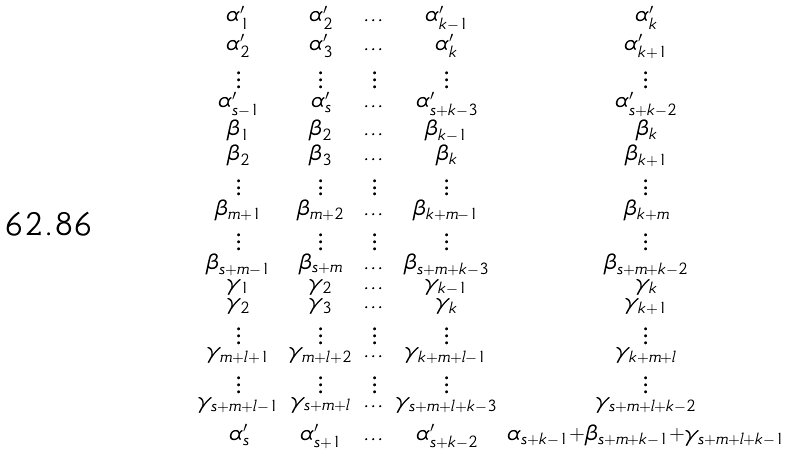Convert formula to latex. <formula><loc_0><loc_0><loc_500><loc_500>\begin{smallmatrix} \alpha _ { 1 } ^ { \prime } & \alpha _ { 2 } ^ { \prime } & \dots & \alpha _ { k - 1 } ^ { \prime } & \alpha _ { k } ^ { \prime } \\ \alpha _ { 2 } ^ { \prime } & \alpha _ { 3 } ^ { \prime } & \dots & \alpha _ { k } ^ { \prime } & \alpha _ { k + 1 } ^ { \prime } \\ \vdots & \vdots & \vdots & \vdots & \vdots \\ \alpha _ { s - 1 } ^ { \prime } & \alpha _ { s } ^ { \prime } & \dots & \alpha _ { s + k - 3 } ^ { \prime } & \alpha _ { s + k - 2 } ^ { \prime } \\ \beta _ { 1 } & \beta _ { 2 } & \dots & \beta _ { k - 1 } & \beta _ { k } \\ \beta _ { 2 } & \beta _ { 3 } & \dots & \beta _ { k } & \beta _ { k + 1 } \\ \vdots & \vdots & \vdots & \vdots & \vdots \\ \beta _ { m + 1 } & \beta _ { m + 2 } & \dots & \beta _ { k + m - 1 } & \beta _ { k + m } \\ \vdots & \vdots & \vdots & \vdots & \vdots \\ \beta _ { s + m - 1 } & \beta _ { s + m } & \dots & \beta _ { s + m + k - 3 } & \beta _ { s + m + k - 2 } \\ \gamma _ { 1 } & \gamma _ { 2 } & \dots & \gamma _ { k - 1 } & \gamma _ { k } \\ \gamma _ { 2 } & \gamma _ { 3 } & \dots & \gamma _ { k } & \gamma _ { k + 1 } \\ \vdots & \vdots & \vdots & \vdots & \vdots \\ \gamma _ { m + l + 1 } & \gamma _ { m + l + 2 } & \dots & \gamma _ { k + m + l - 1 } & \gamma _ { k + m + l } \\ \vdots & \vdots & \vdots & \vdots & \vdots \\ \gamma _ { s + m + l - 1 } & \gamma _ { s + m + l } & \dots & \gamma _ { s + m + l + k - 3 } & \gamma _ { s + m + l + k - 2 } \\ \\ \alpha _ { s } ^ { \prime } & \alpha _ { s + 1 } ^ { \prime } & \dots & \alpha _ { s + k - 2 } ^ { \prime } & \alpha _ { s + k - 1 } + \beta _ { s + m + k - 1 } + \gamma _ { s + m + l + k - 1 } \end{smallmatrix}</formula> 